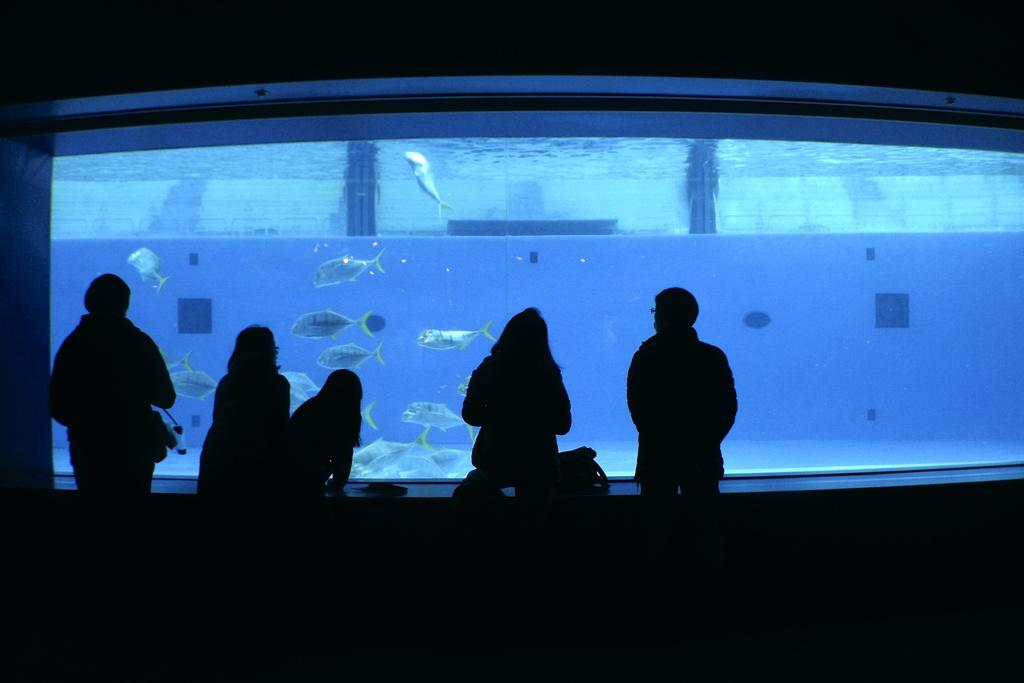What are the people in the image doing? The people in the image are standing in front of an aquarium. What can be found inside the aquarium? The aquarium contains fishes. How many rings are visible on the fishes in the image? There are no rings visible on the fishes in the image, as they are not wearing any. Can you describe the type of fish that is flying in the image? There is no fish flying in the image; the fishes are inside the aquarium. 